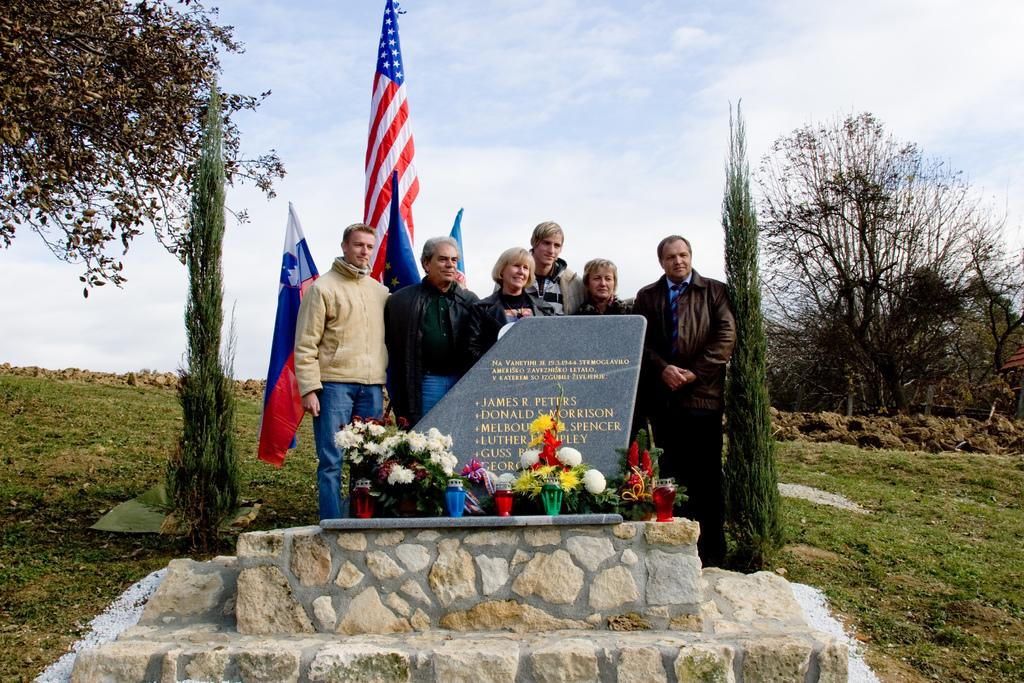What can be seen in the background of the image? There are trees in the image. What objects are present in the image that represent a country or cause? There are flags in the image. What type of flora is visible in the image? There are colorful flowers in the image. What is the color of the sky in the image? The sky is blue and white in color. Can you describe the girl playing with the rings in the image? There is no girl or rings present in the image. What effect does the presence of the trees have on the overall mood of the image? The provided facts do not mention any mood or emotion associated with the image, so it is not possible to determine the effect of the trees on the mood. 